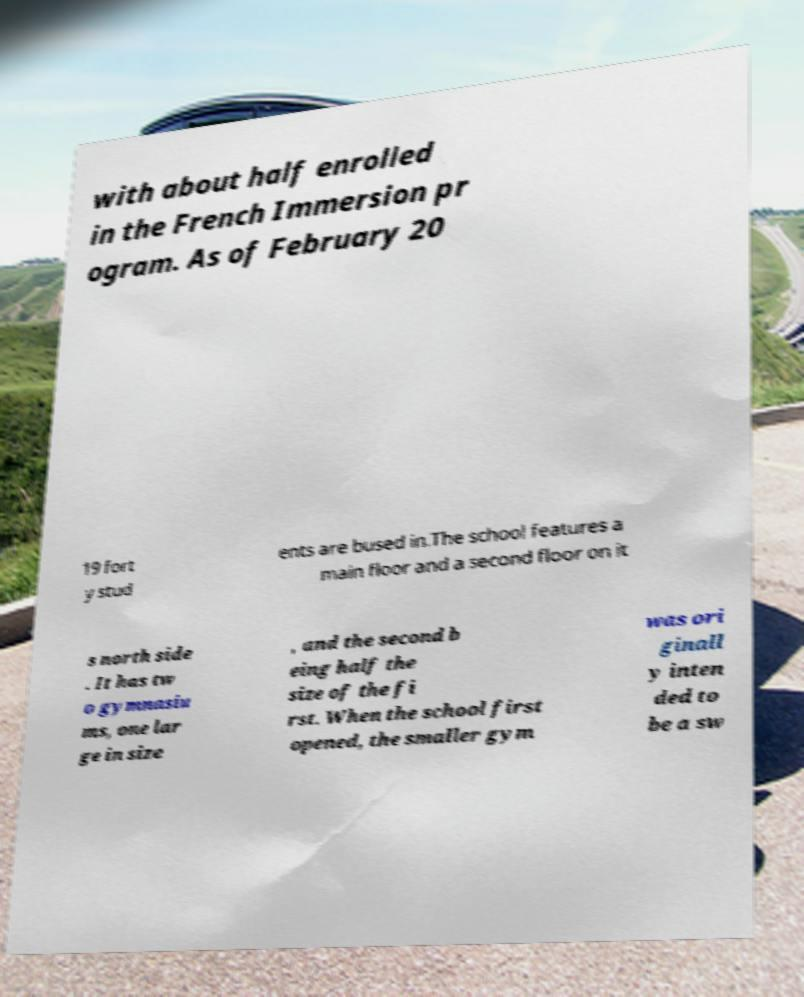Could you assist in decoding the text presented in this image and type it out clearly? with about half enrolled in the French Immersion pr ogram. As of February 20 19 fort y stud ents are bused in.The school features a main floor and a second floor on it s north side . It has tw o gymnasiu ms, one lar ge in size , and the second b eing half the size of the fi rst. When the school first opened, the smaller gym was ori ginall y inten ded to be a sw 